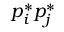Convert formula to latex. <formula><loc_0><loc_0><loc_500><loc_500>p _ { i } ^ { * } p _ { j } ^ { * }</formula> 